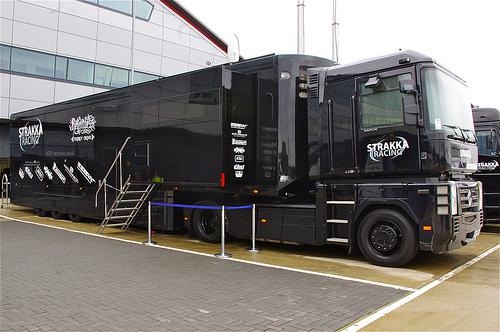Question: what color are the trucks?
Choices:
A. Brown.
B. Blue.
C. Black.
D. Red.
Answer with the letter. Answer: C Question: where do the stairs leave?
Choices:
A. Into the basement.
B. Into the truck.
C. From the attic.
D. Out of the pool.
Answer with the letter. Answer: B Question: what does the sign on the truck door say?
Choices:
A. Strakka Racing.
B. Caution.
C. Stops at tracks.
D. Ups.
Answer with the letter. Answer: A Question: what is the clear thing on the front of the truck?
Choices:
A. Windshield.
B. Glass.
C. A Window.
D. Cover.
Answer with the letter. Answer: C 